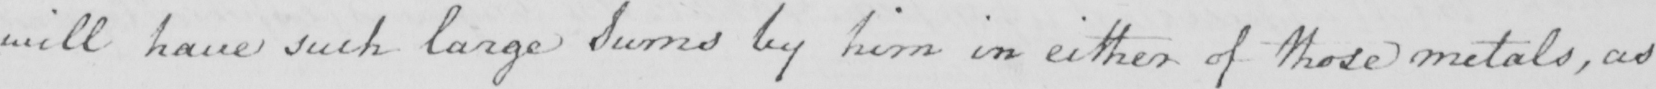Can you tell me what this handwritten text says? will have such large Sums by him in either of those metals , as 